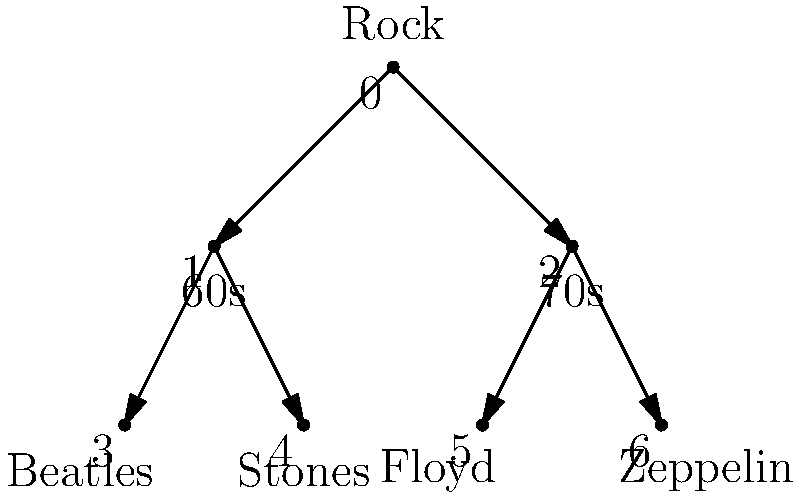You're organizing your vinyl collection using a tree diagram. The root represents the genre "Rock," with two subcategories for decades (60s and 70s). Each decade has two iconic bands. If you want to add a new category for "80s Rock" with two bands, how many nodes will the tree have in total? Let's approach this step-by-step:

1. First, let's count the existing nodes in the tree:
   - 1 root node (Rock)
   - 2 decade nodes (60s and 70s)
   - 4 band nodes (Beatles, Stones, Floyd, Zeppelin)
   - Total existing nodes: $1 + 2 + 4 = 7$

2. Now, we need to add the new category:
   - 1 new decade node (80s)
   - 2 new band nodes for the 80s

3. Calculate the total:
   - Existing nodes: 7
   - New nodes: $1 + 2 = 3$
   - Total nodes: $7 + 3 = 10$

Therefore, after adding the new category, the tree will have 10 nodes in total.
Answer: 10 nodes 